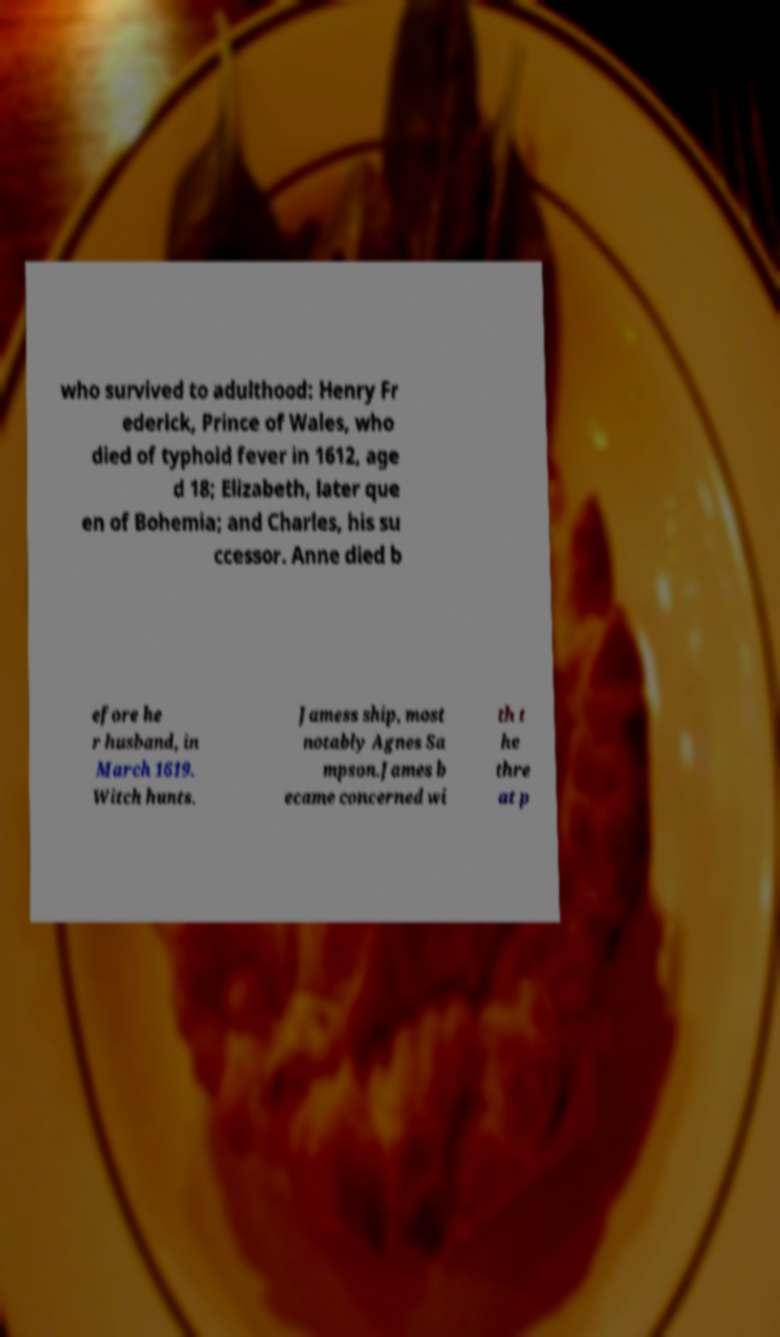Can you read and provide the text displayed in the image?This photo seems to have some interesting text. Can you extract and type it out for me? who survived to adulthood: Henry Fr ederick, Prince of Wales, who died of typhoid fever in 1612, age d 18; Elizabeth, later que en of Bohemia; and Charles, his su ccessor. Anne died b efore he r husband, in March 1619. Witch hunts. Jamess ship, most notably Agnes Sa mpson.James b ecame concerned wi th t he thre at p 